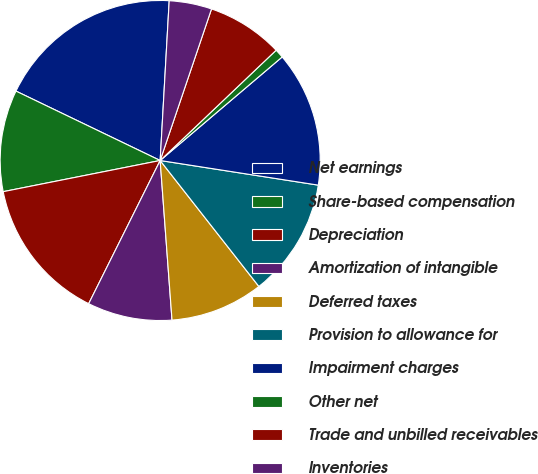<chart> <loc_0><loc_0><loc_500><loc_500><pie_chart><fcel>Net earnings<fcel>Share-based compensation<fcel>Depreciation<fcel>Amortization of intangible<fcel>Deferred taxes<fcel>Provision to allowance for<fcel>Impairment charges<fcel>Other net<fcel>Trade and unbilled receivables<fcel>Inventories<nl><fcel>18.76%<fcel>10.26%<fcel>14.51%<fcel>8.55%<fcel>9.4%<fcel>11.96%<fcel>13.66%<fcel>0.9%<fcel>7.7%<fcel>4.3%<nl></chart> 